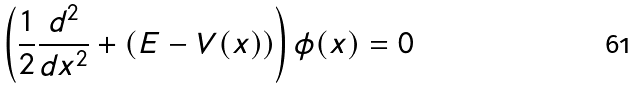Convert formula to latex. <formula><loc_0><loc_0><loc_500><loc_500>\left ( \frac { 1 } { 2 } \frac { d ^ { 2 } } { d x ^ { 2 } } + ( E - V ( x ) ) \right ) \phi ( x ) = 0</formula> 